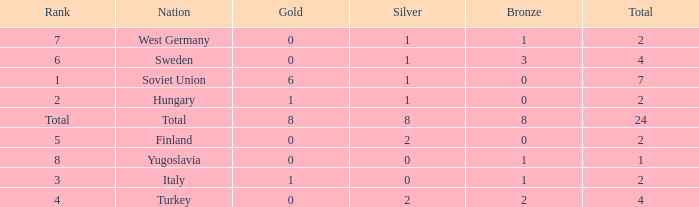What is the minimal bronze, when gold is below 0? None. 